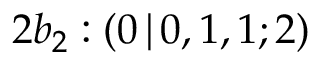Convert formula to latex. <formula><loc_0><loc_0><loc_500><loc_500>2 b _ { 2 } \colon ( 0 \, | \, 0 , 1 , 1 ; 2 )</formula> 